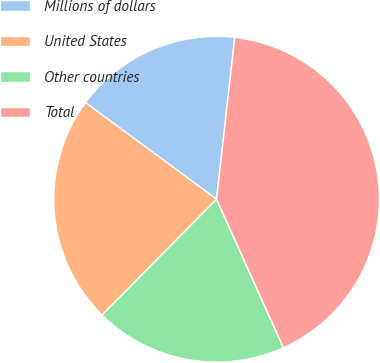Convert chart to OTSL. <chart><loc_0><loc_0><loc_500><loc_500><pie_chart><fcel>Millions of dollars<fcel>United States<fcel>Other countries<fcel>Total<nl><fcel>16.67%<fcel>22.7%<fcel>19.15%<fcel>41.49%<nl></chart> 